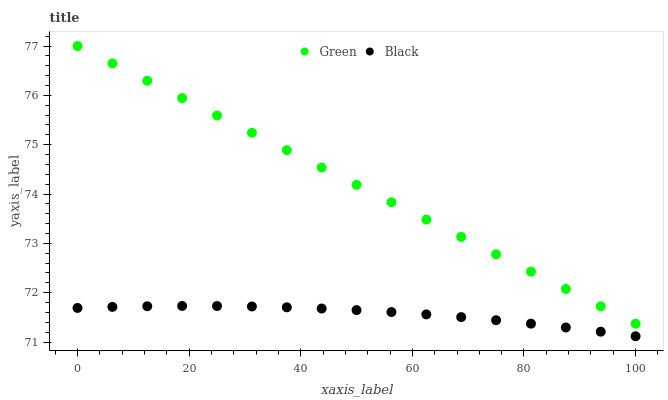Does Black have the minimum area under the curve?
Answer yes or no. Yes. Does Green have the maximum area under the curve?
Answer yes or no. Yes. Does Green have the minimum area under the curve?
Answer yes or no. No. Is Green the smoothest?
Answer yes or no. Yes. Is Black the roughest?
Answer yes or no. Yes. Is Green the roughest?
Answer yes or no. No. Does Black have the lowest value?
Answer yes or no. Yes. Does Green have the lowest value?
Answer yes or no. No. Does Green have the highest value?
Answer yes or no. Yes. Is Black less than Green?
Answer yes or no. Yes. Is Green greater than Black?
Answer yes or no. Yes. Does Black intersect Green?
Answer yes or no. No. 